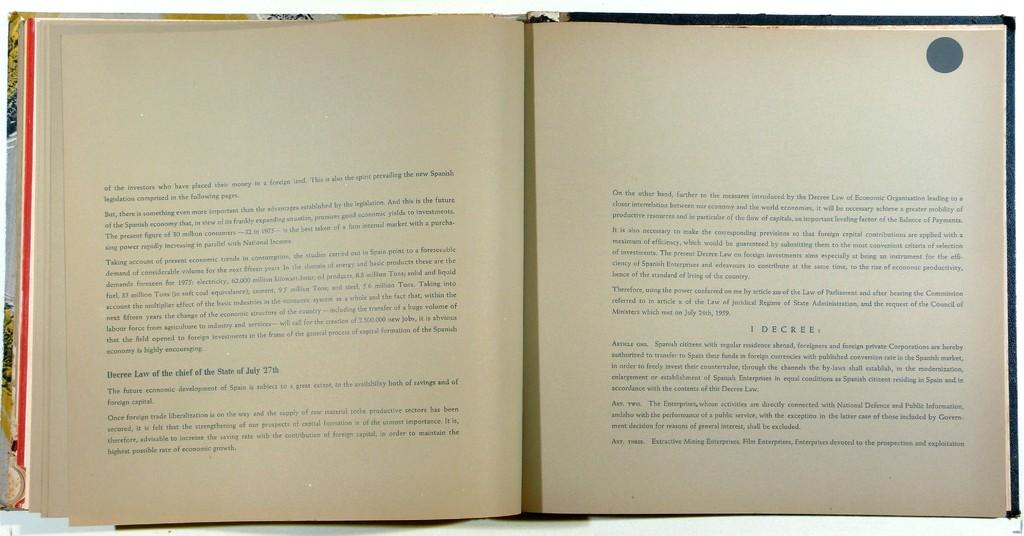<image>
Offer a succinct explanation of the picture presented. An open book that appears to be on the law. 